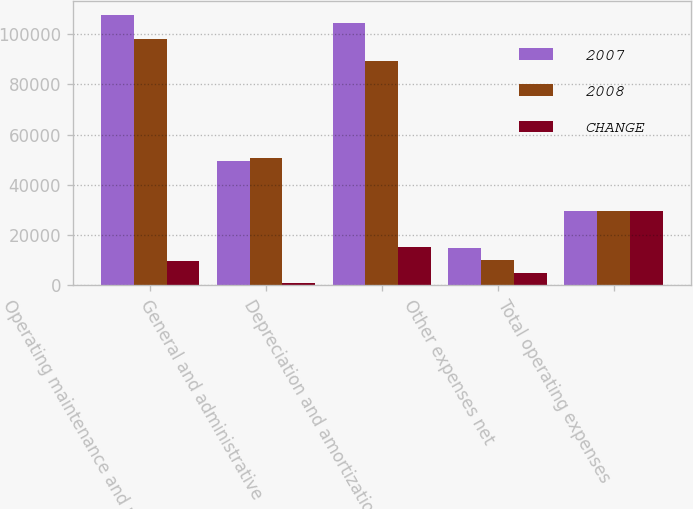Convert chart to OTSL. <chart><loc_0><loc_0><loc_500><loc_500><stacked_bar_chart><ecel><fcel>Operating maintenance and real<fcel>General and administrative<fcel>Depreciation and amortization<fcel>Other expenses net<fcel>Total operating expenses<nl><fcel>2007<fcel>107652<fcel>49495<fcel>104569<fcel>14824<fcel>29798<nl><fcel>2008<fcel>97910<fcel>50580<fcel>89365<fcel>10057<fcel>29798<nl><fcel>CHANGE<fcel>9742<fcel>1085<fcel>15204<fcel>4767<fcel>29798<nl></chart> 